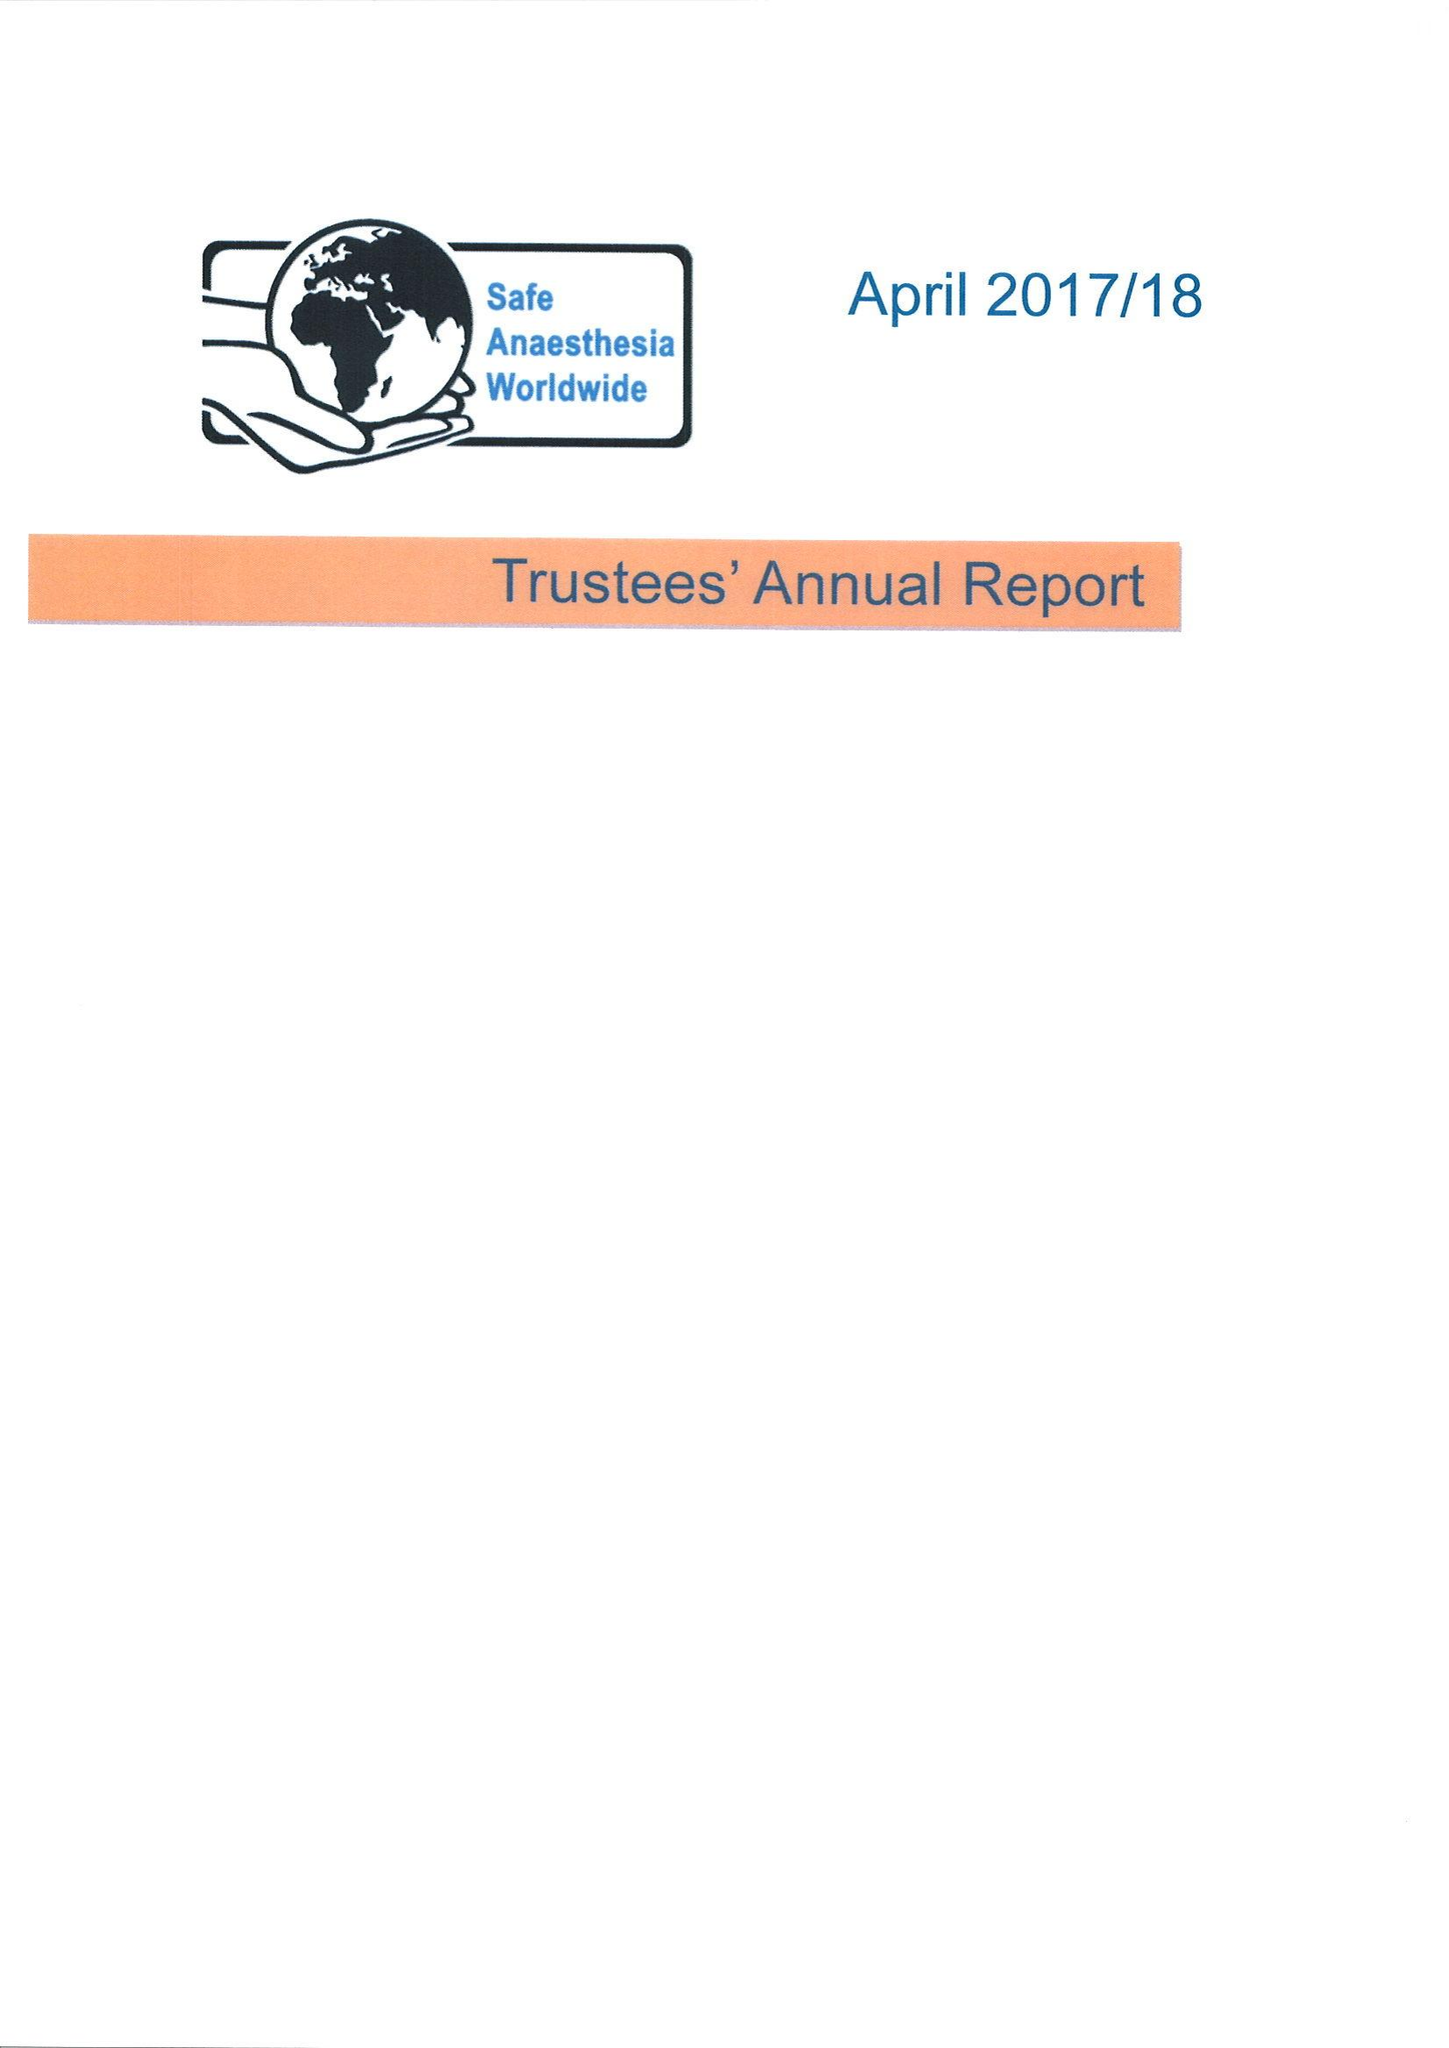What is the value for the charity_number?
Answer the question using a single word or phrase. 1148254 